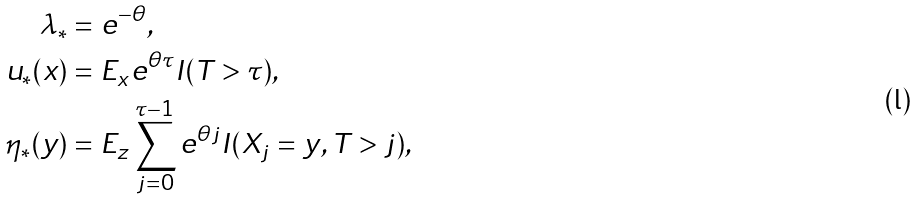Convert formula to latex. <formula><loc_0><loc_0><loc_500><loc_500>\lambda _ { * } & = e ^ { - \theta } , \\ u _ { * } ( x ) & = E _ { x } e ^ { \theta \tau } I ( T > \tau ) , \\ \eta _ { * } ( y ) & = E _ { z } \sum _ { j = 0 } ^ { \tau - 1 } e ^ { \theta j } I ( X _ { j } = y , T > j ) ,</formula> 